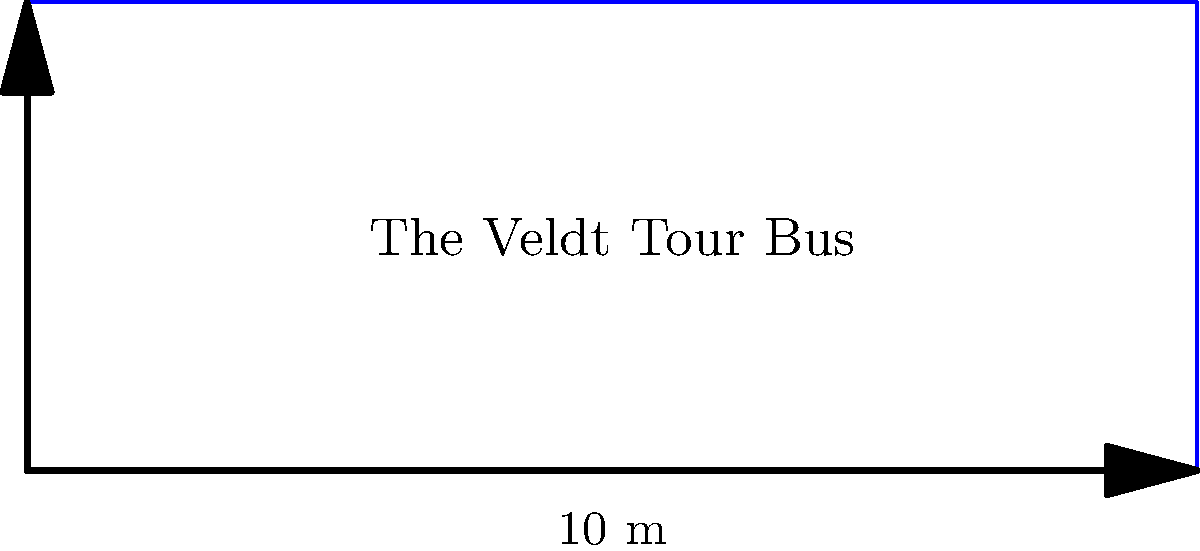The Veldt's new tour bus needs a rectangular wrap featuring their logo. If the bus measures 10 meters in length and 4 meters in height, what is the perimeter of the wrap needed to cover all four sides of the bus? To calculate the perimeter of the rectangular tour bus wrap, we need to follow these steps:

1. Identify the dimensions:
   Length (l) = 10 meters
   Height (h) = 4 meters

2. Recall the formula for the perimeter of a rectangle:
   Perimeter = 2 * (length + height)

3. Substitute the values into the formula:
   Perimeter = 2 * (10 m + 4 m)

4. Perform the addition inside the parentheses:
   Perimeter = 2 * (14 m)

5. Multiply:
   Perimeter = 28 meters

Therefore, the perimeter of the wrap needed to cover all four sides of The Veldt's tour bus is 28 meters.
Answer: 28 meters 